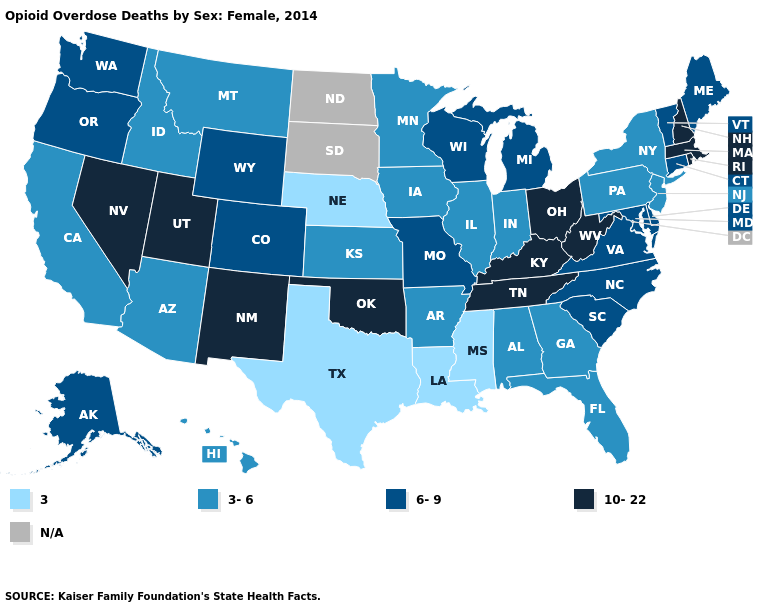Among the states that border Minnesota , does Iowa have the highest value?
Quick response, please. No. What is the value of Alaska?
Give a very brief answer. 6-9. Does the first symbol in the legend represent the smallest category?
Keep it brief. Yes. What is the highest value in the USA?
Quick response, please. 10-22. Among the states that border Minnesota , does Wisconsin have the highest value?
Be succinct. Yes. Name the states that have a value in the range 3-6?
Give a very brief answer. Alabama, Arizona, Arkansas, California, Florida, Georgia, Hawaii, Idaho, Illinois, Indiana, Iowa, Kansas, Minnesota, Montana, New Jersey, New York, Pennsylvania. Does Nebraska have the lowest value in the USA?
Write a very short answer. Yes. Does the first symbol in the legend represent the smallest category?
Concise answer only. Yes. Which states have the lowest value in the Northeast?
Quick response, please. New Jersey, New York, Pennsylvania. Does the map have missing data?
Answer briefly. Yes. Does the map have missing data?
Answer briefly. Yes. What is the lowest value in the Northeast?
Quick response, please. 3-6. What is the highest value in states that border Montana?
Answer briefly. 6-9. Does Mississippi have the lowest value in the USA?
Concise answer only. Yes. 